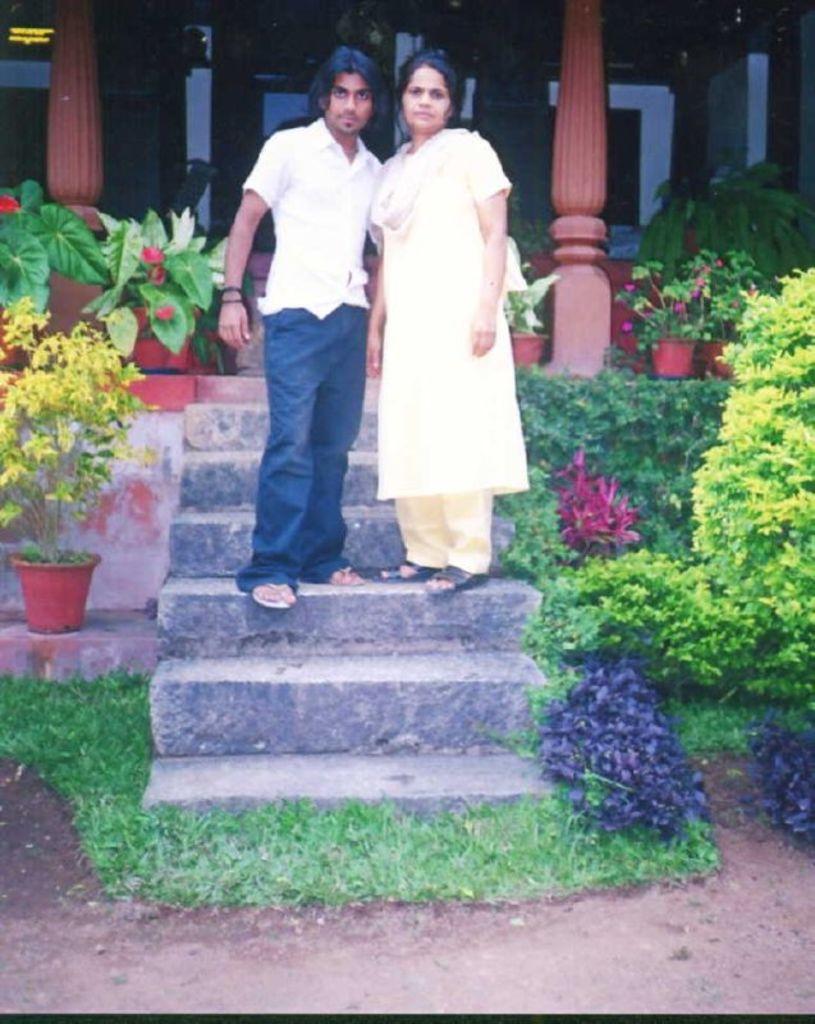Please provide a concise description of this image. In the picture I can see two persons standing on the staircase. I can see a plant pot on the left side. I can see the plants and plant pots on the right side. I can see the pillars of a house at the top of the picture. 